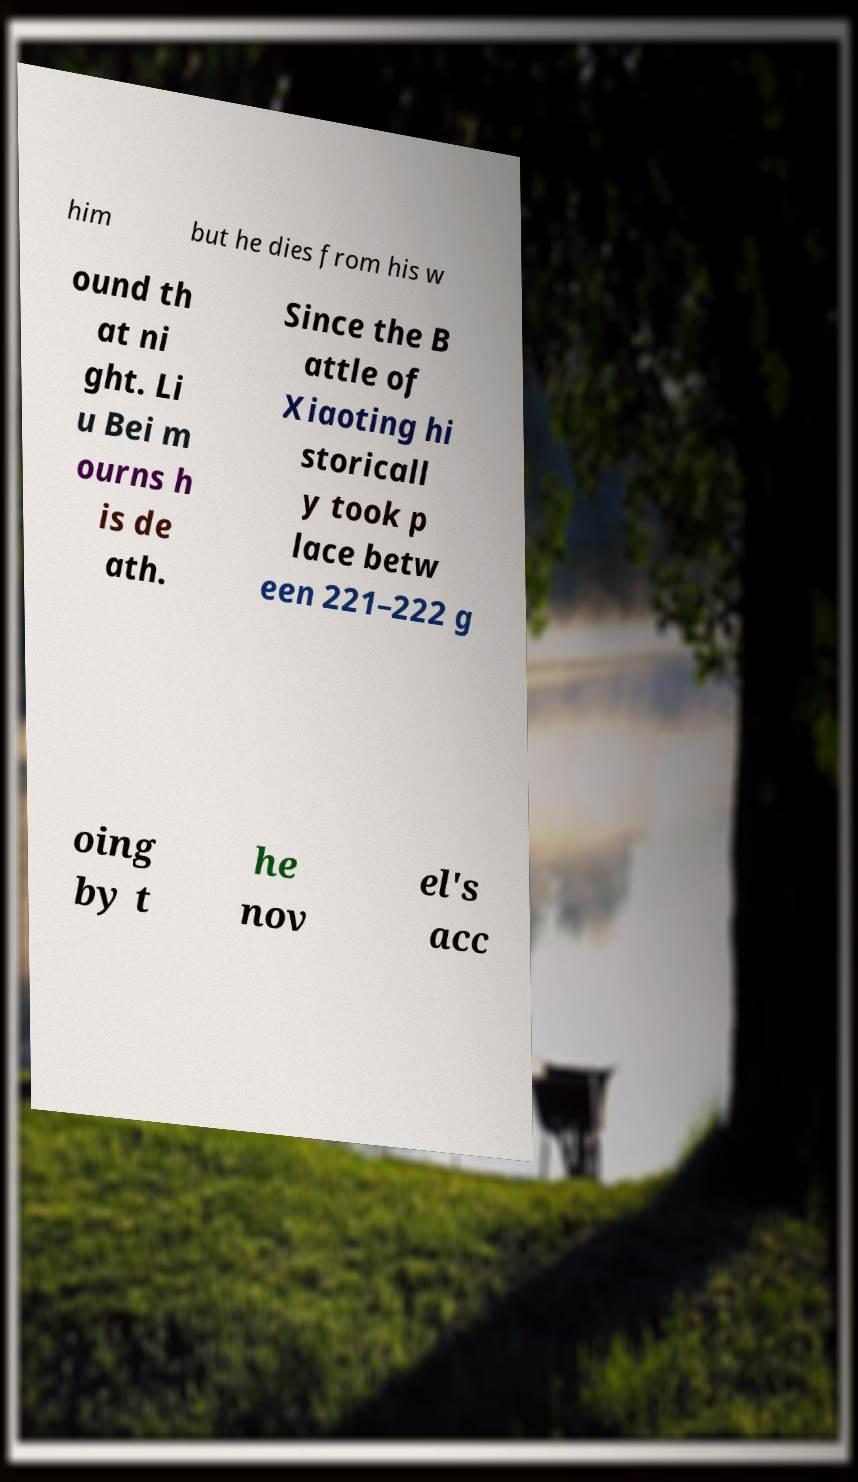For documentation purposes, I need the text within this image transcribed. Could you provide that? him but he dies from his w ound th at ni ght. Li u Bei m ourns h is de ath. Since the B attle of Xiaoting hi storicall y took p lace betw een 221–222 g oing by t he nov el's acc 